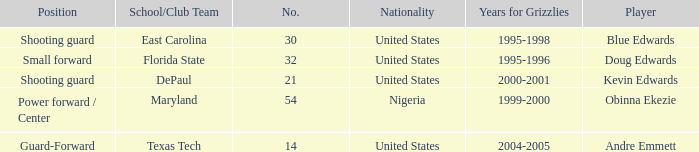What's the highest player number from the list from 2000-2001 21.0. 